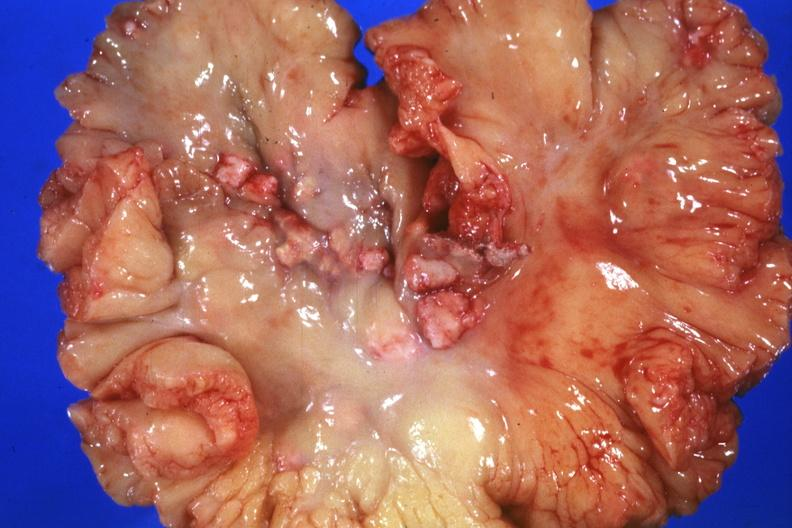does this image show mesentery with involved nodes?
Answer the question using a single word or phrase. Yes 